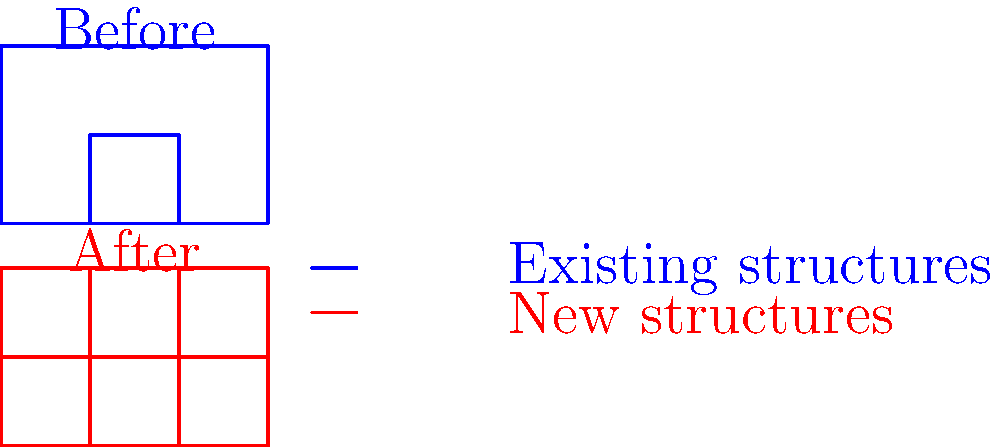Analyze the before-and-after satellite images of an urban development project. What is the percentage increase in the number of structures after the development? To determine the percentage increase in the number of structures:

1. Count the structures in the "Before" image:
   - 1 large rectangle
   - 1 small rectangle inside
   Total: 2 structures

2. Count the structures in the "After" image:
   - 1 large rectangle (unchanged)
   - 3 smaller rectangles inside
   Total: 4 structures

3. Calculate the increase in number:
   $4 - 2 = 2$ new structures

4. Calculate the percentage increase:
   Percentage increase = $\frac{\text{Increase}}{\text{Original}} \times 100\%$
   $= \frac{2}{2} \times 100\% = 100\%$

Therefore, the percentage increase in the number of structures is 100%.
Answer: 100% 